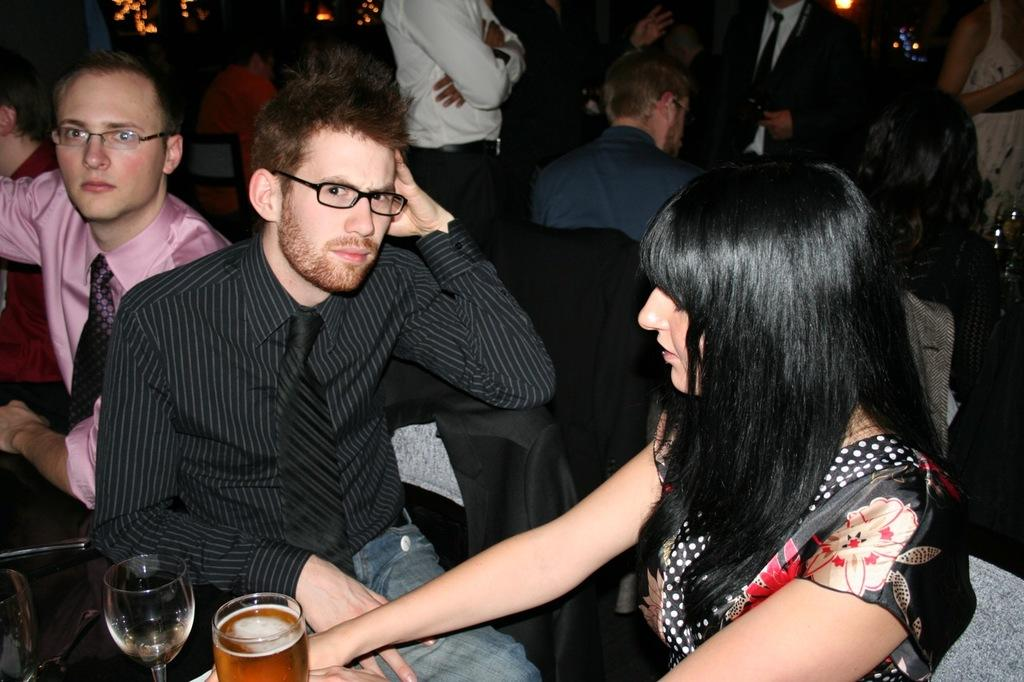What are the people in the image doing? There are people sitting on chairs and standing in the image. Can you describe the man in the image? A man is present in the image. What is in front of the man? There are glasses in front of the man. What can be seen in the background of the image? There are lights visible in the background of the image. What type of sign can be seen warning about pollution in the image? There is no sign present in the image, nor is there any mention of pollution. 